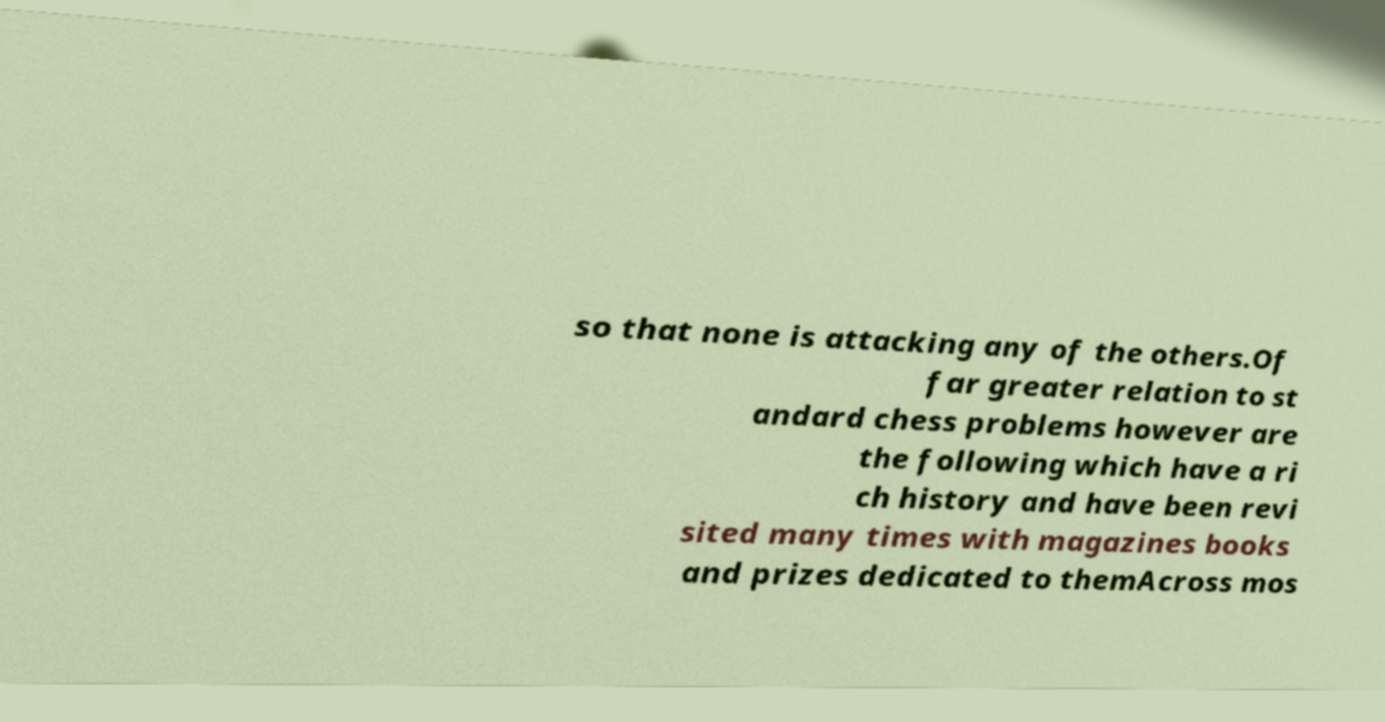For documentation purposes, I need the text within this image transcribed. Could you provide that? so that none is attacking any of the others.Of far greater relation to st andard chess problems however are the following which have a ri ch history and have been revi sited many times with magazines books and prizes dedicated to themAcross mos 